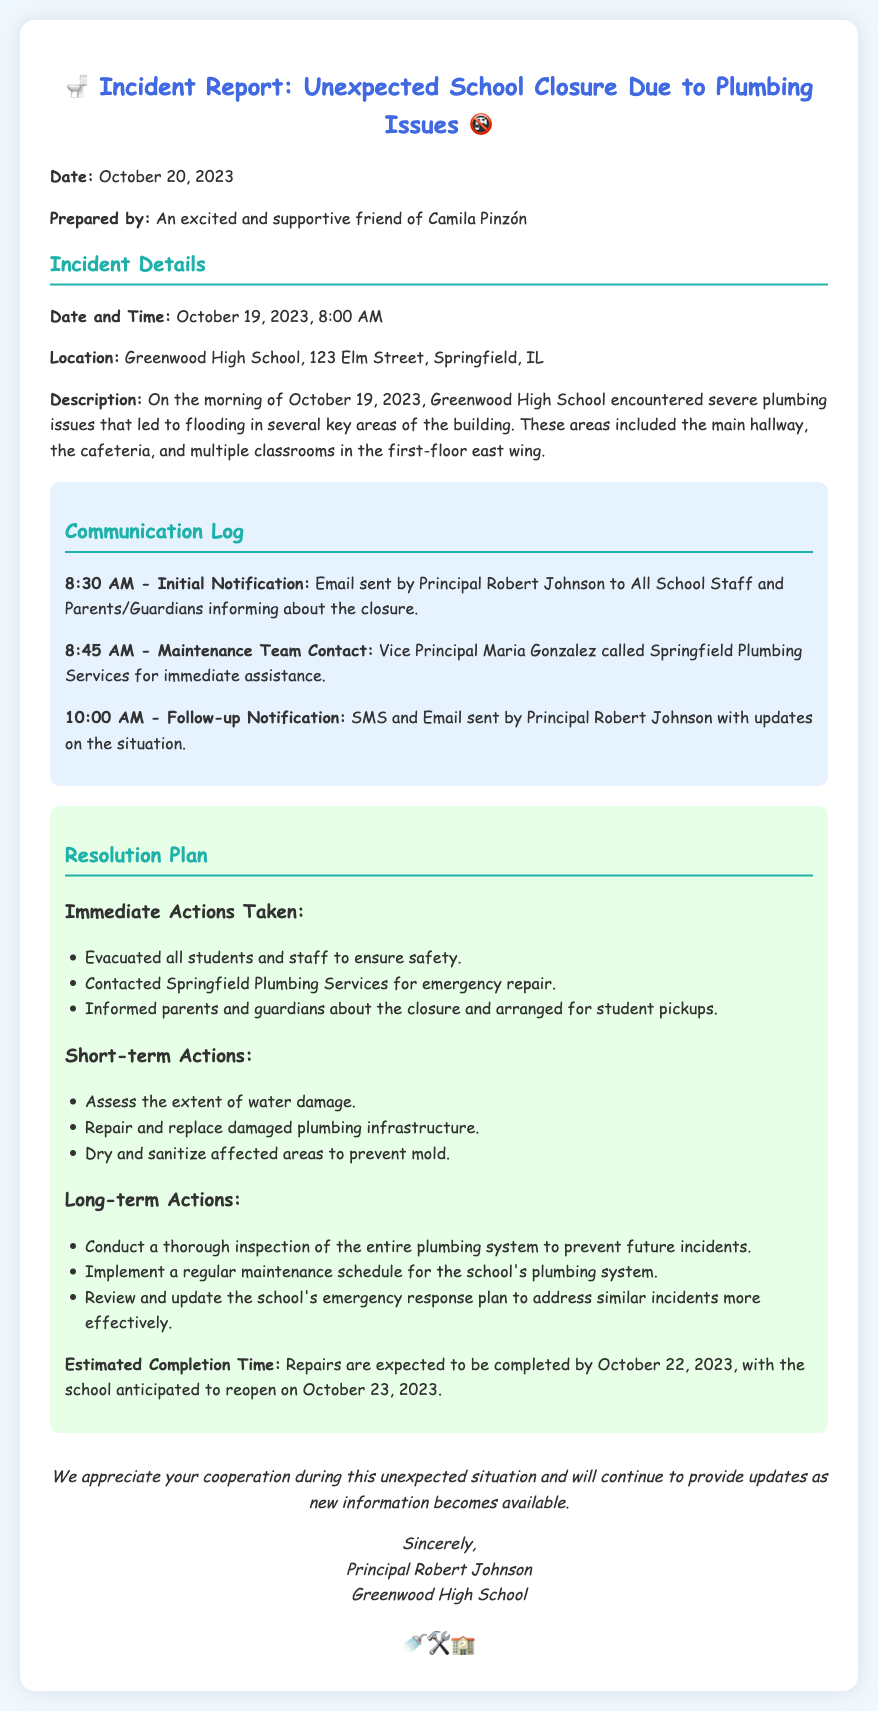What was the date of the incident? The date of the incident is specified in the document as October 19, 2023.
Answer: October 19, 2023 Who prepared this incident report? The report states it was prepared by "An excited and supportive friend of Camila Pinzón".
Answer: An excited and supportive friend of Camila Pinzón What time was the initial notification sent? The communication log indicates that the initial notification was sent at 8:30 AM.
Answer: 8:30 AM What is the expected school reopening date? The document mentions that the school is anticipated to reopen on October 23, 2023.
Answer: October 23, 2023 What immediate action was taken for safety? The report lists that all students and staff were evacuated to ensure safety.
Answer: Evacuated all students and staff What role did Vice Principal Maria Gonzalez play? The document notes that she contacted Springfield Plumbing Services for immediate assistance.
Answer: Contacted Springfield Plumbing Services What type of incident is reported? The title of the document clearly states it is about an "Unexpected School Closure Due to Plumbing Issues".
Answer: Plumbing Issues What is one long-term action planned? The resolution plan includes conducting a thorough inspection of the entire plumbing system.
Answer: Conduct a thorough inspection 